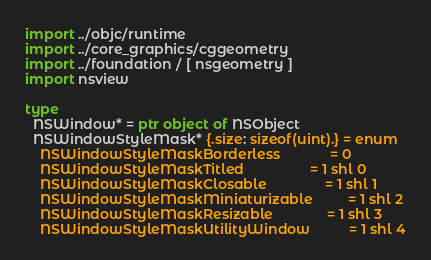<code> <loc_0><loc_0><loc_500><loc_500><_Nim_>import ../objc/runtime
import ../core_graphics/cggeometry
import ../foundation / [ nsgeometry ]
import nsview

type 
  NSWindow* = ptr object of NSObject
  NSWindowStyleMask* {.size: sizeof(uint).} = enum
    NSWindowStyleMaskBorderless             = 0
    NSWindowStyleMaskTitled                 = 1 shl 0
    NSWindowStyleMaskClosable               = 1 shl 1
    NSWindowStyleMaskMiniaturizable         = 1 shl 2
    NSWindowStyleMaskResizable              = 1 shl 3
    NSWindowStyleMaskUtilityWindow          = 1 shl 4</code> 